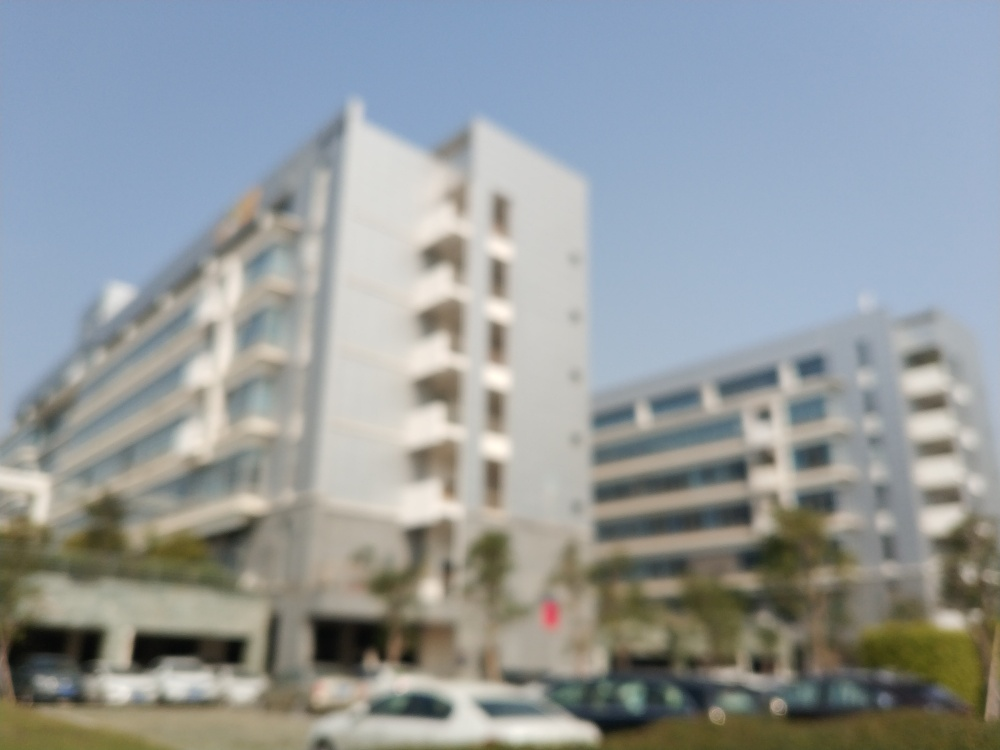Can you describe the clarity of the objects in this picture? The objects in the picture exhibit a substantial lack of clarity, resulting in an image that's predominantly undefined and lacks crispness. It appears to be an out-of-focus photograph of buildings. 